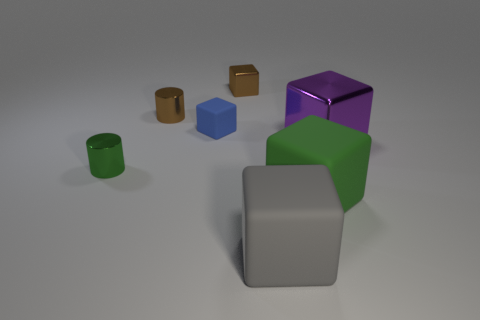Subtract all small brown metal blocks. How many blocks are left? 4 Add 1 small brown cylinders. How many objects exist? 8 Subtract all blue blocks. How many blocks are left? 4 Subtract 2 cylinders. How many cylinders are left? 0 Add 4 purple metallic objects. How many purple metallic objects exist? 5 Subtract 0 yellow blocks. How many objects are left? 7 Subtract all cylinders. How many objects are left? 5 Subtract all purple cylinders. Subtract all brown blocks. How many cylinders are left? 2 Subtract all metallic blocks. Subtract all green rubber things. How many objects are left? 4 Add 6 blue rubber cubes. How many blue rubber cubes are left? 7 